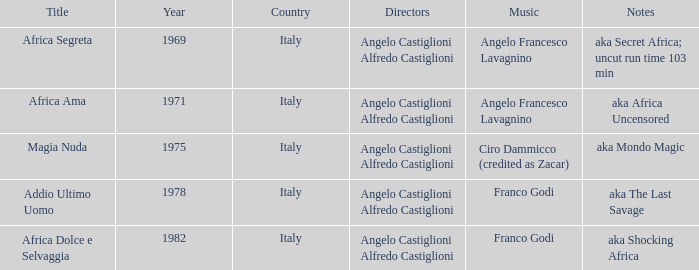What is the country that has a music writer of Angelo Francesco Lavagnino, written in 1969? Italy. 